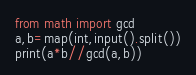Convert code to text. <code><loc_0><loc_0><loc_500><loc_500><_Python_>from math import gcd
a,b=map(int,input().split())
print(a*b//gcd(a,b))
</code> 